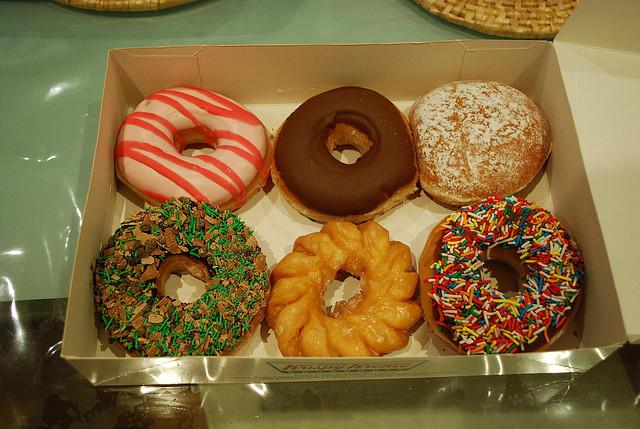How many doughnuts have sprinkles?
Be succinct. 2. How many consumable items are pictured?
Write a very short answer. 6. What is on the top-middle doughnut?
Write a very short answer. Chocolate. How many types of doughnuts are there?
Answer briefly. 6. What flavor is the frosting on the cross hatched doughnuts?
Give a very brief answer. Strawberry. How many donuts are there?
Keep it brief. 6. Where were the doughnuts purchased?
Give a very brief answer. Krispy kreme. Are all the donuts decorated?
Write a very short answer. No. 